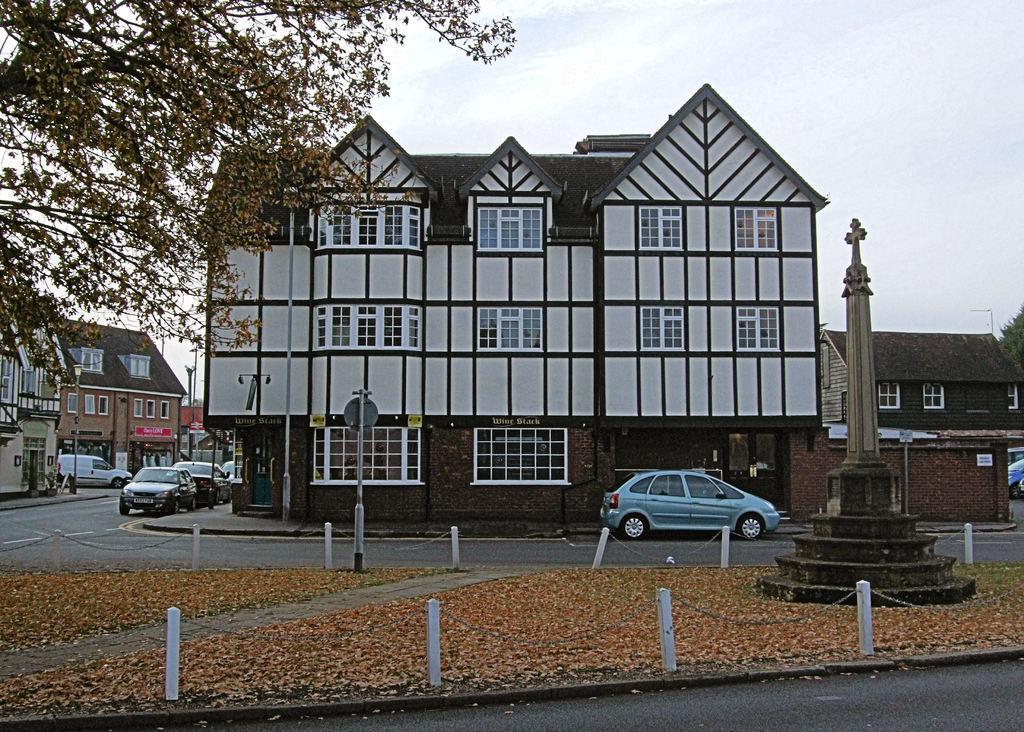In one or two sentences, can you explain what this image depicts? This image is taken outdoors. At the top of the image there is the sky with clouds. At the bottom of the image there is a road and there are many dry leaves on the road. In the background there are a few buildings with walls, windows, doors and roofs. There are a few trees. A few cars are parked on the road and there are a few poles. In the middle of the image a car is parked on the road. On the right side of the image a car is parked on the road and there is a statue of a cross symbol. 